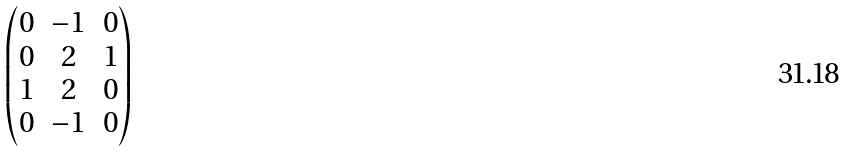<formula> <loc_0><loc_0><loc_500><loc_500>\begin{pmatrix} 0 & - 1 & 0 \\ 0 & 2 & 1 \\ 1 & 2 & 0 \\ 0 & - 1 & 0 \end{pmatrix}</formula> 